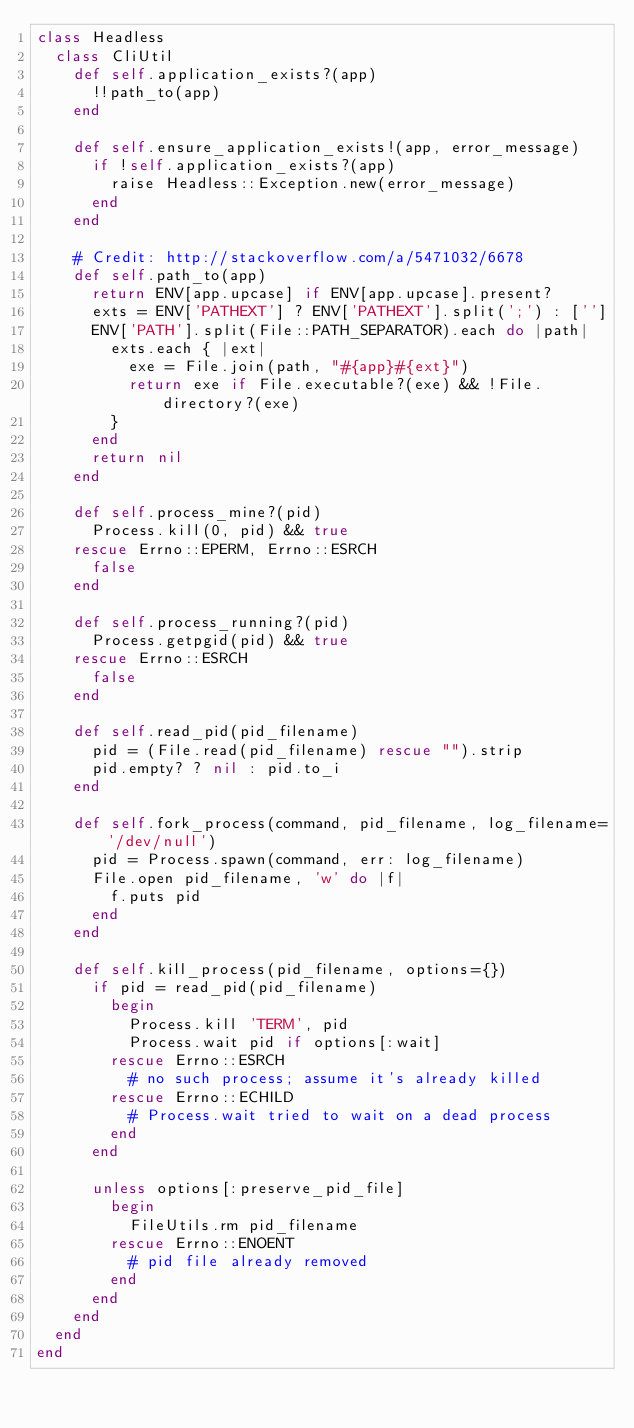<code> <loc_0><loc_0><loc_500><loc_500><_Ruby_>class Headless
  class CliUtil
    def self.application_exists?(app)
      !!path_to(app)
    end

    def self.ensure_application_exists!(app, error_message)
      if !self.application_exists?(app)
        raise Headless::Exception.new(error_message)
      end
    end

    # Credit: http://stackoverflow.com/a/5471032/6678
    def self.path_to(app)
      return ENV[app.upcase] if ENV[app.upcase].present?
      exts = ENV['PATHEXT'] ? ENV['PATHEXT'].split(';') : ['']
      ENV['PATH'].split(File::PATH_SEPARATOR).each do |path|
        exts.each { |ext|
          exe = File.join(path, "#{app}#{ext}")
          return exe if File.executable?(exe) && !File.directory?(exe)
        }
      end
      return nil
    end

    def self.process_mine?(pid)
      Process.kill(0, pid) && true
    rescue Errno::EPERM, Errno::ESRCH
      false
    end

    def self.process_running?(pid)
      Process.getpgid(pid) && true
    rescue Errno::ESRCH
      false
    end

    def self.read_pid(pid_filename)
      pid = (File.read(pid_filename) rescue "").strip
      pid.empty? ? nil : pid.to_i
    end

    def self.fork_process(command, pid_filename, log_filename='/dev/null')
      pid = Process.spawn(command, err: log_filename)
      File.open pid_filename, 'w' do |f|
        f.puts pid
      end
    end

    def self.kill_process(pid_filename, options={})
      if pid = read_pid(pid_filename)
        begin
          Process.kill 'TERM', pid
          Process.wait pid if options[:wait]
        rescue Errno::ESRCH
          # no such process; assume it's already killed
        rescue Errno::ECHILD
          # Process.wait tried to wait on a dead process
        end
      end

      unless options[:preserve_pid_file]
        begin
          FileUtils.rm pid_filename
        rescue Errno::ENOENT
          # pid file already removed
        end
      end
    end
  end
end
</code> 